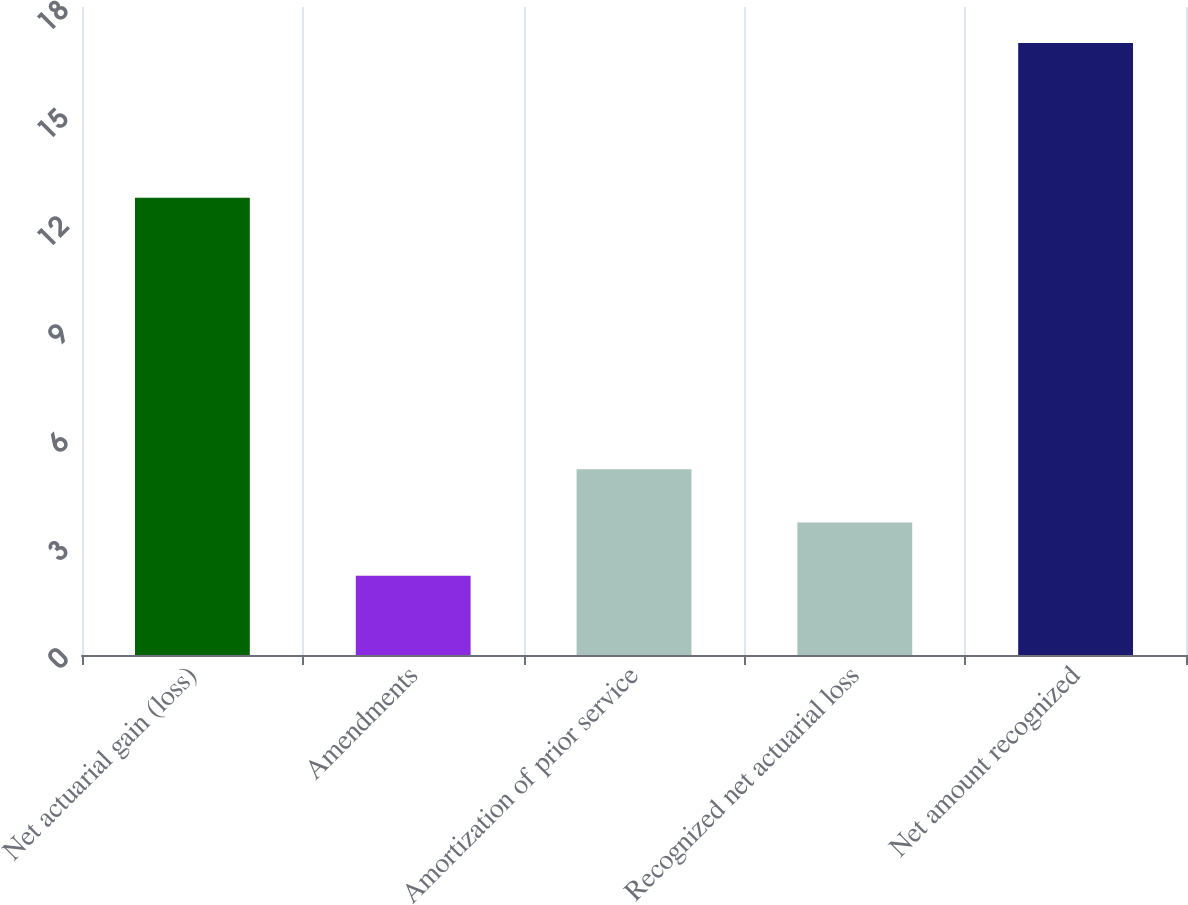<chart> <loc_0><loc_0><loc_500><loc_500><bar_chart><fcel>Net actuarial gain (loss)<fcel>Amendments<fcel>Amortization of prior service<fcel>Recognized net actuarial loss<fcel>Net amount recognized<nl><fcel>12.7<fcel>2.2<fcel>5.16<fcel>3.68<fcel>17<nl></chart> 